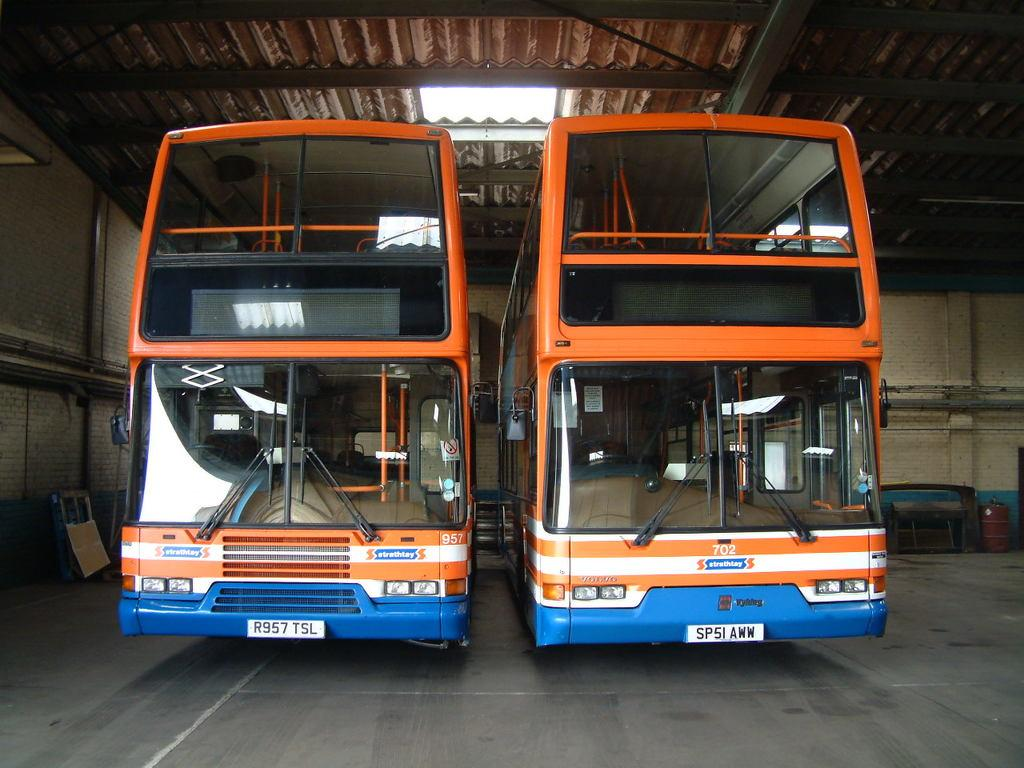What type of vehicles are present in the image? There are double decker buses in the image. Where are the buses located? The buses are inside a shed. What can be seen above the buses in the image? There is a roof visible in the image. What type of nation is represented by the crate in the image? There is no crate present in the image, and therefore no nation can be associated with it. 